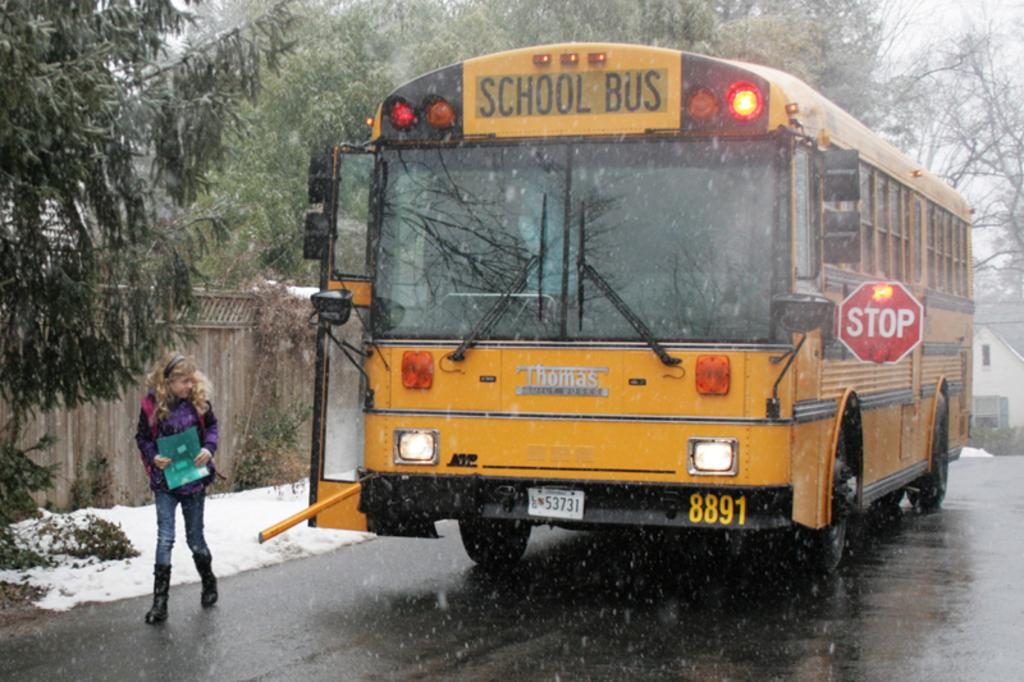What is the main subject in the image? There is a vehicle in the image. Who or what else can be seen in the image? There is a girl on the road in the image, and she is holding a file. What can be seen in the background of the image? There is a wall, a house, trees, and the sky visible in the background of the image. What time of day is it in the image, considering the afternoon? The provided facts do not mention the time of day or any reference to the afternoon. Therefore, we cannot determine the time of day from the image. 